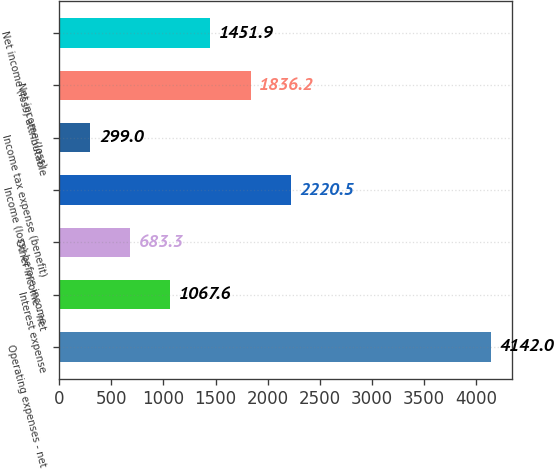Convert chart. <chart><loc_0><loc_0><loc_500><loc_500><bar_chart><fcel>Operating expenses - net<fcel>Interest expense<fcel>Other income - net<fcel>Income (loss) before income<fcel>Income tax expense (benefit)<fcel>Net income (loss)<fcel>Net income (loss) attributable<nl><fcel>4142<fcel>1067.6<fcel>683.3<fcel>2220.5<fcel>299<fcel>1836.2<fcel>1451.9<nl></chart> 